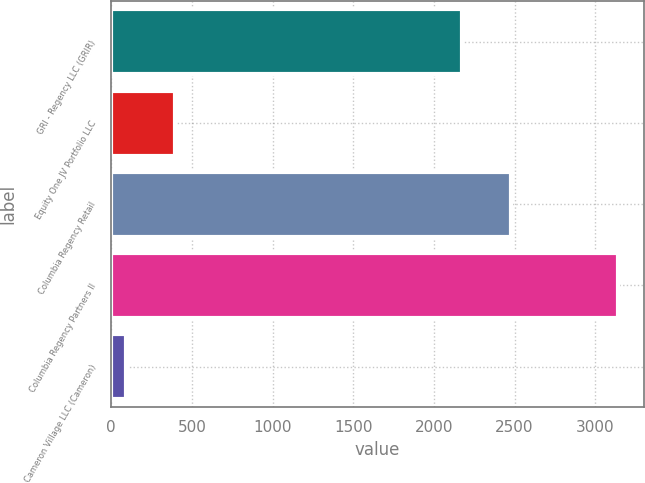Convert chart to OTSL. <chart><loc_0><loc_0><loc_500><loc_500><bar_chart><fcel>GRI - Regency LLC (GRIR)<fcel>Equity One JV Portfolio LLC<fcel>Columbia Regency Retail<fcel>Columbia Regency Partners II<fcel>Cameron Village LLC (Cameron)<nl><fcel>2174<fcel>398<fcel>2479<fcel>3143<fcel>93<nl></chart> 